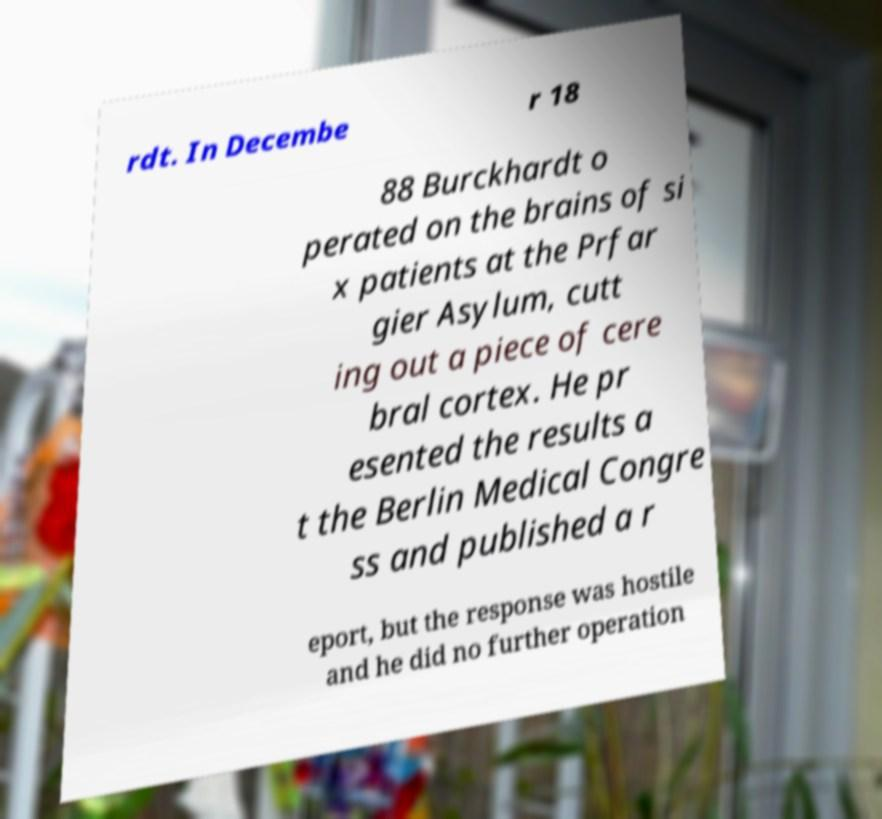There's text embedded in this image that I need extracted. Can you transcribe it verbatim? rdt. In Decembe r 18 88 Burckhardt o perated on the brains of si x patients at the Prfar gier Asylum, cutt ing out a piece of cere bral cortex. He pr esented the results a t the Berlin Medical Congre ss and published a r eport, but the response was hostile and he did no further operation 